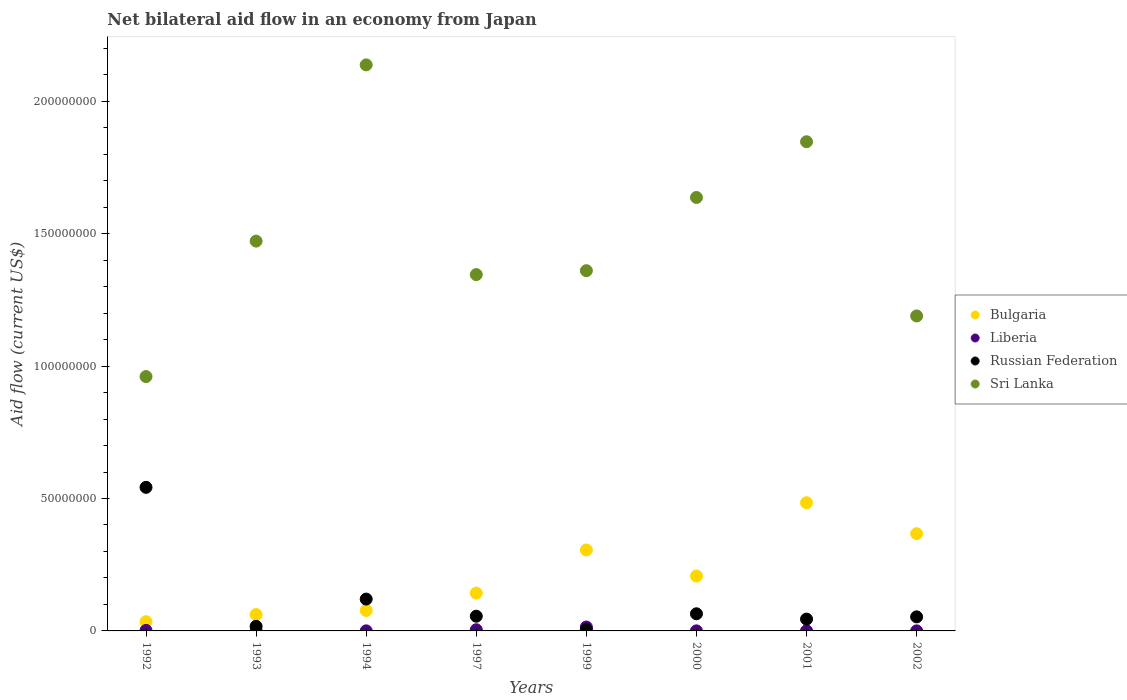What is the net bilateral aid flow in Sri Lanka in 1994?
Keep it short and to the point. 2.14e+08. Across all years, what is the maximum net bilateral aid flow in Liberia?
Ensure brevity in your answer.  1.47e+06. In which year was the net bilateral aid flow in Sri Lanka minimum?
Keep it short and to the point. 1992. What is the total net bilateral aid flow in Russian Federation in the graph?
Your answer should be compact. 9.03e+07. What is the difference between the net bilateral aid flow in Russian Federation in 1993 and that in 2002?
Provide a succinct answer. -3.57e+06. What is the difference between the net bilateral aid flow in Bulgaria in 1993 and the net bilateral aid flow in Liberia in 2001?
Provide a succinct answer. 6.13e+06. What is the average net bilateral aid flow in Sri Lanka per year?
Keep it short and to the point. 1.49e+08. In the year 2002, what is the difference between the net bilateral aid flow in Bulgaria and net bilateral aid flow in Russian Federation?
Your answer should be very brief. 3.14e+07. In how many years, is the net bilateral aid flow in Bulgaria greater than 80000000 US$?
Ensure brevity in your answer.  0. What is the ratio of the net bilateral aid flow in Sri Lanka in 1997 to that in 2002?
Your response must be concise. 1.13. Is the net bilateral aid flow in Bulgaria in 1993 less than that in 2000?
Ensure brevity in your answer.  Yes. Is the difference between the net bilateral aid flow in Bulgaria in 1993 and 2000 greater than the difference between the net bilateral aid flow in Russian Federation in 1993 and 2000?
Ensure brevity in your answer.  No. What is the difference between the highest and the second highest net bilateral aid flow in Bulgaria?
Offer a very short reply. 1.17e+07. What is the difference between the highest and the lowest net bilateral aid flow in Russian Federation?
Ensure brevity in your answer.  5.37e+07. Is the sum of the net bilateral aid flow in Bulgaria in 1999 and 2002 greater than the maximum net bilateral aid flow in Sri Lanka across all years?
Ensure brevity in your answer.  No. Is it the case that in every year, the sum of the net bilateral aid flow in Liberia and net bilateral aid flow in Sri Lanka  is greater than the net bilateral aid flow in Russian Federation?
Your response must be concise. Yes. Is the net bilateral aid flow in Bulgaria strictly greater than the net bilateral aid flow in Liberia over the years?
Offer a terse response. Yes. How many dotlines are there?
Provide a short and direct response. 4. What is the difference between two consecutive major ticks on the Y-axis?
Your answer should be very brief. 5.00e+07. Are the values on the major ticks of Y-axis written in scientific E-notation?
Your answer should be compact. No. Does the graph contain any zero values?
Offer a terse response. No. Does the graph contain grids?
Your answer should be very brief. No. What is the title of the graph?
Offer a very short reply. Net bilateral aid flow in an economy from Japan. Does "European Union" appear as one of the legend labels in the graph?
Provide a succinct answer. No. What is the label or title of the Y-axis?
Give a very brief answer. Aid flow (current US$). What is the Aid flow (current US$) in Bulgaria in 1992?
Keep it short and to the point. 3.48e+06. What is the Aid flow (current US$) of Liberia in 1992?
Ensure brevity in your answer.  2.00e+05. What is the Aid flow (current US$) of Russian Federation in 1992?
Offer a terse response. 5.42e+07. What is the Aid flow (current US$) in Sri Lanka in 1992?
Keep it short and to the point. 9.60e+07. What is the Aid flow (current US$) in Bulgaria in 1993?
Your answer should be very brief. 6.18e+06. What is the Aid flow (current US$) in Liberia in 1993?
Offer a very short reply. 6.00e+04. What is the Aid flow (current US$) in Russian Federation in 1993?
Your answer should be very brief. 1.74e+06. What is the Aid flow (current US$) of Sri Lanka in 1993?
Your response must be concise. 1.47e+08. What is the Aid flow (current US$) of Bulgaria in 1994?
Give a very brief answer. 7.72e+06. What is the Aid flow (current US$) in Russian Federation in 1994?
Offer a very short reply. 1.20e+07. What is the Aid flow (current US$) in Sri Lanka in 1994?
Keep it short and to the point. 2.14e+08. What is the Aid flow (current US$) in Bulgaria in 1997?
Ensure brevity in your answer.  1.43e+07. What is the Aid flow (current US$) in Russian Federation in 1997?
Give a very brief answer. 5.56e+06. What is the Aid flow (current US$) in Sri Lanka in 1997?
Offer a terse response. 1.35e+08. What is the Aid flow (current US$) of Bulgaria in 1999?
Your answer should be compact. 3.06e+07. What is the Aid flow (current US$) in Liberia in 1999?
Offer a very short reply. 1.47e+06. What is the Aid flow (current US$) of Sri Lanka in 1999?
Your answer should be very brief. 1.36e+08. What is the Aid flow (current US$) in Bulgaria in 2000?
Ensure brevity in your answer.  2.07e+07. What is the Aid flow (current US$) in Liberia in 2000?
Provide a succinct answer. 2.00e+04. What is the Aid flow (current US$) in Russian Federation in 2000?
Offer a very short reply. 6.47e+06. What is the Aid flow (current US$) in Sri Lanka in 2000?
Make the answer very short. 1.64e+08. What is the Aid flow (current US$) in Bulgaria in 2001?
Your answer should be very brief. 4.84e+07. What is the Aid flow (current US$) of Liberia in 2001?
Provide a short and direct response. 5.00e+04. What is the Aid flow (current US$) in Russian Federation in 2001?
Your response must be concise. 4.46e+06. What is the Aid flow (current US$) of Sri Lanka in 2001?
Provide a short and direct response. 1.85e+08. What is the Aid flow (current US$) in Bulgaria in 2002?
Offer a very short reply. 3.67e+07. What is the Aid flow (current US$) in Liberia in 2002?
Provide a succinct answer. 2.00e+04. What is the Aid flow (current US$) of Russian Federation in 2002?
Your answer should be compact. 5.31e+06. What is the Aid flow (current US$) of Sri Lanka in 2002?
Ensure brevity in your answer.  1.19e+08. Across all years, what is the maximum Aid flow (current US$) in Bulgaria?
Offer a terse response. 4.84e+07. Across all years, what is the maximum Aid flow (current US$) in Liberia?
Your response must be concise. 1.47e+06. Across all years, what is the maximum Aid flow (current US$) of Russian Federation?
Provide a short and direct response. 5.42e+07. Across all years, what is the maximum Aid flow (current US$) of Sri Lanka?
Your response must be concise. 2.14e+08. Across all years, what is the minimum Aid flow (current US$) of Bulgaria?
Give a very brief answer. 3.48e+06. Across all years, what is the minimum Aid flow (current US$) of Russian Federation?
Give a very brief answer. 5.00e+05. Across all years, what is the minimum Aid flow (current US$) in Sri Lanka?
Offer a very short reply. 9.60e+07. What is the total Aid flow (current US$) of Bulgaria in the graph?
Your response must be concise. 1.68e+08. What is the total Aid flow (current US$) of Liberia in the graph?
Offer a terse response. 2.30e+06. What is the total Aid flow (current US$) of Russian Federation in the graph?
Ensure brevity in your answer.  9.03e+07. What is the total Aid flow (current US$) in Sri Lanka in the graph?
Keep it short and to the point. 1.19e+09. What is the difference between the Aid flow (current US$) of Bulgaria in 1992 and that in 1993?
Your answer should be very brief. -2.70e+06. What is the difference between the Aid flow (current US$) in Liberia in 1992 and that in 1993?
Provide a short and direct response. 1.40e+05. What is the difference between the Aid flow (current US$) of Russian Federation in 1992 and that in 1993?
Provide a short and direct response. 5.25e+07. What is the difference between the Aid flow (current US$) of Sri Lanka in 1992 and that in 1993?
Your answer should be very brief. -5.12e+07. What is the difference between the Aid flow (current US$) of Bulgaria in 1992 and that in 1994?
Your answer should be compact. -4.24e+06. What is the difference between the Aid flow (current US$) in Russian Federation in 1992 and that in 1994?
Your response must be concise. 4.22e+07. What is the difference between the Aid flow (current US$) in Sri Lanka in 1992 and that in 1994?
Give a very brief answer. -1.18e+08. What is the difference between the Aid flow (current US$) of Bulgaria in 1992 and that in 1997?
Your answer should be compact. -1.08e+07. What is the difference between the Aid flow (current US$) of Liberia in 1992 and that in 1997?
Offer a very short reply. -2.50e+05. What is the difference between the Aid flow (current US$) in Russian Federation in 1992 and that in 1997?
Provide a succinct answer. 4.87e+07. What is the difference between the Aid flow (current US$) in Sri Lanka in 1992 and that in 1997?
Provide a short and direct response. -3.85e+07. What is the difference between the Aid flow (current US$) in Bulgaria in 1992 and that in 1999?
Give a very brief answer. -2.71e+07. What is the difference between the Aid flow (current US$) of Liberia in 1992 and that in 1999?
Provide a succinct answer. -1.27e+06. What is the difference between the Aid flow (current US$) in Russian Federation in 1992 and that in 1999?
Make the answer very short. 5.37e+07. What is the difference between the Aid flow (current US$) of Sri Lanka in 1992 and that in 1999?
Provide a succinct answer. -4.00e+07. What is the difference between the Aid flow (current US$) of Bulgaria in 1992 and that in 2000?
Offer a very short reply. -1.72e+07. What is the difference between the Aid flow (current US$) in Russian Federation in 1992 and that in 2000?
Your answer should be very brief. 4.78e+07. What is the difference between the Aid flow (current US$) in Sri Lanka in 1992 and that in 2000?
Ensure brevity in your answer.  -6.76e+07. What is the difference between the Aid flow (current US$) in Bulgaria in 1992 and that in 2001?
Make the answer very short. -4.49e+07. What is the difference between the Aid flow (current US$) in Liberia in 1992 and that in 2001?
Ensure brevity in your answer.  1.50e+05. What is the difference between the Aid flow (current US$) in Russian Federation in 1992 and that in 2001?
Keep it short and to the point. 4.98e+07. What is the difference between the Aid flow (current US$) in Sri Lanka in 1992 and that in 2001?
Your response must be concise. -8.87e+07. What is the difference between the Aid flow (current US$) of Bulgaria in 1992 and that in 2002?
Give a very brief answer. -3.32e+07. What is the difference between the Aid flow (current US$) in Russian Federation in 1992 and that in 2002?
Offer a very short reply. 4.89e+07. What is the difference between the Aid flow (current US$) of Sri Lanka in 1992 and that in 2002?
Your answer should be compact. -2.29e+07. What is the difference between the Aid flow (current US$) of Bulgaria in 1993 and that in 1994?
Provide a succinct answer. -1.54e+06. What is the difference between the Aid flow (current US$) of Liberia in 1993 and that in 1994?
Keep it short and to the point. 3.00e+04. What is the difference between the Aid flow (current US$) in Russian Federation in 1993 and that in 1994?
Keep it short and to the point. -1.03e+07. What is the difference between the Aid flow (current US$) of Sri Lanka in 1993 and that in 1994?
Keep it short and to the point. -6.66e+07. What is the difference between the Aid flow (current US$) in Bulgaria in 1993 and that in 1997?
Ensure brevity in your answer.  -8.11e+06. What is the difference between the Aid flow (current US$) of Liberia in 1993 and that in 1997?
Make the answer very short. -3.90e+05. What is the difference between the Aid flow (current US$) of Russian Federation in 1993 and that in 1997?
Provide a succinct answer. -3.82e+06. What is the difference between the Aid flow (current US$) of Sri Lanka in 1993 and that in 1997?
Offer a terse response. 1.26e+07. What is the difference between the Aid flow (current US$) in Bulgaria in 1993 and that in 1999?
Offer a terse response. -2.44e+07. What is the difference between the Aid flow (current US$) of Liberia in 1993 and that in 1999?
Ensure brevity in your answer.  -1.41e+06. What is the difference between the Aid flow (current US$) in Russian Federation in 1993 and that in 1999?
Ensure brevity in your answer.  1.24e+06. What is the difference between the Aid flow (current US$) in Sri Lanka in 1993 and that in 1999?
Your answer should be compact. 1.12e+07. What is the difference between the Aid flow (current US$) in Bulgaria in 1993 and that in 2000?
Provide a short and direct response. -1.46e+07. What is the difference between the Aid flow (current US$) of Russian Federation in 1993 and that in 2000?
Offer a very short reply. -4.73e+06. What is the difference between the Aid flow (current US$) in Sri Lanka in 1993 and that in 2000?
Give a very brief answer. -1.65e+07. What is the difference between the Aid flow (current US$) in Bulgaria in 1993 and that in 2001?
Offer a terse response. -4.22e+07. What is the difference between the Aid flow (current US$) of Russian Federation in 1993 and that in 2001?
Make the answer very short. -2.72e+06. What is the difference between the Aid flow (current US$) of Sri Lanka in 1993 and that in 2001?
Ensure brevity in your answer.  -3.75e+07. What is the difference between the Aid flow (current US$) of Bulgaria in 1993 and that in 2002?
Give a very brief answer. -3.06e+07. What is the difference between the Aid flow (current US$) of Liberia in 1993 and that in 2002?
Your answer should be very brief. 4.00e+04. What is the difference between the Aid flow (current US$) in Russian Federation in 1993 and that in 2002?
Provide a succinct answer. -3.57e+06. What is the difference between the Aid flow (current US$) in Sri Lanka in 1993 and that in 2002?
Offer a terse response. 2.83e+07. What is the difference between the Aid flow (current US$) in Bulgaria in 1994 and that in 1997?
Make the answer very short. -6.57e+06. What is the difference between the Aid flow (current US$) of Liberia in 1994 and that in 1997?
Offer a terse response. -4.20e+05. What is the difference between the Aid flow (current US$) of Russian Federation in 1994 and that in 1997?
Give a very brief answer. 6.46e+06. What is the difference between the Aid flow (current US$) in Sri Lanka in 1994 and that in 1997?
Your response must be concise. 7.92e+07. What is the difference between the Aid flow (current US$) in Bulgaria in 1994 and that in 1999?
Your answer should be compact. -2.28e+07. What is the difference between the Aid flow (current US$) of Liberia in 1994 and that in 1999?
Ensure brevity in your answer.  -1.44e+06. What is the difference between the Aid flow (current US$) of Russian Federation in 1994 and that in 1999?
Ensure brevity in your answer.  1.15e+07. What is the difference between the Aid flow (current US$) of Sri Lanka in 1994 and that in 1999?
Your answer should be very brief. 7.77e+07. What is the difference between the Aid flow (current US$) in Bulgaria in 1994 and that in 2000?
Give a very brief answer. -1.30e+07. What is the difference between the Aid flow (current US$) in Russian Federation in 1994 and that in 2000?
Make the answer very short. 5.55e+06. What is the difference between the Aid flow (current US$) in Sri Lanka in 1994 and that in 2000?
Your answer should be very brief. 5.01e+07. What is the difference between the Aid flow (current US$) of Bulgaria in 1994 and that in 2001?
Ensure brevity in your answer.  -4.07e+07. What is the difference between the Aid flow (current US$) of Liberia in 1994 and that in 2001?
Give a very brief answer. -2.00e+04. What is the difference between the Aid flow (current US$) in Russian Federation in 1994 and that in 2001?
Provide a short and direct response. 7.56e+06. What is the difference between the Aid flow (current US$) of Sri Lanka in 1994 and that in 2001?
Give a very brief answer. 2.90e+07. What is the difference between the Aid flow (current US$) of Bulgaria in 1994 and that in 2002?
Keep it short and to the point. -2.90e+07. What is the difference between the Aid flow (current US$) in Liberia in 1994 and that in 2002?
Provide a succinct answer. 10000. What is the difference between the Aid flow (current US$) of Russian Federation in 1994 and that in 2002?
Offer a very short reply. 6.71e+06. What is the difference between the Aid flow (current US$) of Sri Lanka in 1994 and that in 2002?
Provide a short and direct response. 9.48e+07. What is the difference between the Aid flow (current US$) in Bulgaria in 1997 and that in 1999?
Keep it short and to the point. -1.63e+07. What is the difference between the Aid flow (current US$) in Liberia in 1997 and that in 1999?
Give a very brief answer. -1.02e+06. What is the difference between the Aid flow (current US$) of Russian Federation in 1997 and that in 1999?
Your answer should be very brief. 5.06e+06. What is the difference between the Aid flow (current US$) in Sri Lanka in 1997 and that in 1999?
Offer a terse response. -1.47e+06. What is the difference between the Aid flow (current US$) in Bulgaria in 1997 and that in 2000?
Make the answer very short. -6.44e+06. What is the difference between the Aid flow (current US$) of Liberia in 1997 and that in 2000?
Your response must be concise. 4.30e+05. What is the difference between the Aid flow (current US$) of Russian Federation in 1997 and that in 2000?
Your answer should be compact. -9.10e+05. What is the difference between the Aid flow (current US$) of Sri Lanka in 1997 and that in 2000?
Give a very brief answer. -2.91e+07. What is the difference between the Aid flow (current US$) of Bulgaria in 1997 and that in 2001?
Provide a short and direct response. -3.41e+07. What is the difference between the Aid flow (current US$) in Russian Federation in 1997 and that in 2001?
Keep it short and to the point. 1.10e+06. What is the difference between the Aid flow (current US$) of Sri Lanka in 1997 and that in 2001?
Provide a succinct answer. -5.02e+07. What is the difference between the Aid flow (current US$) of Bulgaria in 1997 and that in 2002?
Your answer should be compact. -2.24e+07. What is the difference between the Aid flow (current US$) of Russian Federation in 1997 and that in 2002?
Keep it short and to the point. 2.50e+05. What is the difference between the Aid flow (current US$) in Sri Lanka in 1997 and that in 2002?
Give a very brief answer. 1.56e+07. What is the difference between the Aid flow (current US$) of Bulgaria in 1999 and that in 2000?
Your answer should be compact. 9.84e+06. What is the difference between the Aid flow (current US$) in Liberia in 1999 and that in 2000?
Make the answer very short. 1.45e+06. What is the difference between the Aid flow (current US$) of Russian Federation in 1999 and that in 2000?
Provide a succinct answer. -5.97e+06. What is the difference between the Aid flow (current US$) of Sri Lanka in 1999 and that in 2000?
Your answer should be compact. -2.76e+07. What is the difference between the Aid flow (current US$) in Bulgaria in 1999 and that in 2001?
Offer a very short reply. -1.78e+07. What is the difference between the Aid flow (current US$) of Liberia in 1999 and that in 2001?
Give a very brief answer. 1.42e+06. What is the difference between the Aid flow (current US$) in Russian Federation in 1999 and that in 2001?
Ensure brevity in your answer.  -3.96e+06. What is the difference between the Aid flow (current US$) of Sri Lanka in 1999 and that in 2001?
Make the answer very short. -4.87e+07. What is the difference between the Aid flow (current US$) in Bulgaria in 1999 and that in 2002?
Offer a terse response. -6.16e+06. What is the difference between the Aid flow (current US$) of Liberia in 1999 and that in 2002?
Make the answer very short. 1.45e+06. What is the difference between the Aid flow (current US$) of Russian Federation in 1999 and that in 2002?
Ensure brevity in your answer.  -4.81e+06. What is the difference between the Aid flow (current US$) in Sri Lanka in 1999 and that in 2002?
Keep it short and to the point. 1.71e+07. What is the difference between the Aid flow (current US$) in Bulgaria in 2000 and that in 2001?
Your response must be concise. -2.77e+07. What is the difference between the Aid flow (current US$) of Liberia in 2000 and that in 2001?
Ensure brevity in your answer.  -3.00e+04. What is the difference between the Aid flow (current US$) of Russian Federation in 2000 and that in 2001?
Your answer should be very brief. 2.01e+06. What is the difference between the Aid flow (current US$) in Sri Lanka in 2000 and that in 2001?
Your response must be concise. -2.10e+07. What is the difference between the Aid flow (current US$) of Bulgaria in 2000 and that in 2002?
Make the answer very short. -1.60e+07. What is the difference between the Aid flow (current US$) in Liberia in 2000 and that in 2002?
Give a very brief answer. 0. What is the difference between the Aid flow (current US$) of Russian Federation in 2000 and that in 2002?
Your answer should be very brief. 1.16e+06. What is the difference between the Aid flow (current US$) in Sri Lanka in 2000 and that in 2002?
Keep it short and to the point. 4.47e+07. What is the difference between the Aid flow (current US$) in Bulgaria in 2001 and that in 2002?
Your response must be concise. 1.17e+07. What is the difference between the Aid flow (current US$) in Russian Federation in 2001 and that in 2002?
Give a very brief answer. -8.50e+05. What is the difference between the Aid flow (current US$) in Sri Lanka in 2001 and that in 2002?
Ensure brevity in your answer.  6.58e+07. What is the difference between the Aid flow (current US$) in Bulgaria in 1992 and the Aid flow (current US$) in Liberia in 1993?
Keep it short and to the point. 3.42e+06. What is the difference between the Aid flow (current US$) in Bulgaria in 1992 and the Aid flow (current US$) in Russian Federation in 1993?
Give a very brief answer. 1.74e+06. What is the difference between the Aid flow (current US$) in Bulgaria in 1992 and the Aid flow (current US$) in Sri Lanka in 1993?
Your answer should be compact. -1.44e+08. What is the difference between the Aid flow (current US$) in Liberia in 1992 and the Aid flow (current US$) in Russian Federation in 1993?
Give a very brief answer. -1.54e+06. What is the difference between the Aid flow (current US$) of Liberia in 1992 and the Aid flow (current US$) of Sri Lanka in 1993?
Provide a short and direct response. -1.47e+08. What is the difference between the Aid flow (current US$) in Russian Federation in 1992 and the Aid flow (current US$) in Sri Lanka in 1993?
Your response must be concise. -9.30e+07. What is the difference between the Aid flow (current US$) in Bulgaria in 1992 and the Aid flow (current US$) in Liberia in 1994?
Offer a terse response. 3.45e+06. What is the difference between the Aid flow (current US$) in Bulgaria in 1992 and the Aid flow (current US$) in Russian Federation in 1994?
Make the answer very short. -8.54e+06. What is the difference between the Aid flow (current US$) of Bulgaria in 1992 and the Aid flow (current US$) of Sri Lanka in 1994?
Make the answer very short. -2.10e+08. What is the difference between the Aid flow (current US$) in Liberia in 1992 and the Aid flow (current US$) in Russian Federation in 1994?
Give a very brief answer. -1.18e+07. What is the difference between the Aid flow (current US$) of Liberia in 1992 and the Aid flow (current US$) of Sri Lanka in 1994?
Your answer should be compact. -2.14e+08. What is the difference between the Aid flow (current US$) in Russian Federation in 1992 and the Aid flow (current US$) in Sri Lanka in 1994?
Provide a succinct answer. -1.60e+08. What is the difference between the Aid flow (current US$) in Bulgaria in 1992 and the Aid flow (current US$) in Liberia in 1997?
Offer a terse response. 3.03e+06. What is the difference between the Aid flow (current US$) in Bulgaria in 1992 and the Aid flow (current US$) in Russian Federation in 1997?
Your response must be concise. -2.08e+06. What is the difference between the Aid flow (current US$) in Bulgaria in 1992 and the Aid flow (current US$) in Sri Lanka in 1997?
Provide a short and direct response. -1.31e+08. What is the difference between the Aid flow (current US$) in Liberia in 1992 and the Aid flow (current US$) in Russian Federation in 1997?
Your answer should be very brief. -5.36e+06. What is the difference between the Aid flow (current US$) in Liberia in 1992 and the Aid flow (current US$) in Sri Lanka in 1997?
Your answer should be compact. -1.34e+08. What is the difference between the Aid flow (current US$) in Russian Federation in 1992 and the Aid flow (current US$) in Sri Lanka in 1997?
Offer a very short reply. -8.03e+07. What is the difference between the Aid flow (current US$) in Bulgaria in 1992 and the Aid flow (current US$) in Liberia in 1999?
Your answer should be very brief. 2.01e+06. What is the difference between the Aid flow (current US$) in Bulgaria in 1992 and the Aid flow (current US$) in Russian Federation in 1999?
Make the answer very short. 2.98e+06. What is the difference between the Aid flow (current US$) in Bulgaria in 1992 and the Aid flow (current US$) in Sri Lanka in 1999?
Provide a short and direct response. -1.33e+08. What is the difference between the Aid flow (current US$) in Liberia in 1992 and the Aid flow (current US$) in Russian Federation in 1999?
Your response must be concise. -3.00e+05. What is the difference between the Aid flow (current US$) in Liberia in 1992 and the Aid flow (current US$) in Sri Lanka in 1999?
Your answer should be compact. -1.36e+08. What is the difference between the Aid flow (current US$) of Russian Federation in 1992 and the Aid flow (current US$) of Sri Lanka in 1999?
Ensure brevity in your answer.  -8.18e+07. What is the difference between the Aid flow (current US$) in Bulgaria in 1992 and the Aid flow (current US$) in Liberia in 2000?
Provide a short and direct response. 3.46e+06. What is the difference between the Aid flow (current US$) of Bulgaria in 1992 and the Aid flow (current US$) of Russian Federation in 2000?
Offer a very short reply. -2.99e+06. What is the difference between the Aid flow (current US$) of Bulgaria in 1992 and the Aid flow (current US$) of Sri Lanka in 2000?
Ensure brevity in your answer.  -1.60e+08. What is the difference between the Aid flow (current US$) in Liberia in 1992 and the Aid flow (current US$) in Russian Federation in 2000?
Give a very brief answer. -6.27e+06. What is the difference between the Aid flow (current US$) in Liberia in 1992 and the Aid flow (current US$) in Sri Lanka in 2000?
Provide a short and direct response. -1.63e+08. What is the difference between the Aid flow (current US$) of Russian Federation in 1992 and the Aid flow (current US$) of Sri Lanka in 2000?
Offer a very short reply. -1.09e+08. What is the difference between the Aid flow (current US$) in Bulgaria in 1992 and the Aid flow (current US$) in Liberia in 2001?
Ensure brevity in your answer.  3.43e+06. What is the difference between the Aid flow (current US$) in Bulgaria in 1992 and the Aid flow (current US$) in Russian Federation in 2001?
Give a very brief answer. -9.80e+05. What is the difference between the Aid flow (current US$) of Bulgaria in 1992 and the Aid flow (current US$) of Sri Lanka in 2001?
Ensure brevity in your answer.  -1.81e+08. What is the difference between the Aid flow (current US$) in Liberia in 1992 and the Aid flow (current US$) in Russian Federation in 2001?
Your answer should be very brief. -4.26e+06. What is the difference between the Aid flow (current US$) of Liberia in 1992 and the Aid flow (current US$) of Sri Lanka in 2001?
Provide a succinct answer. -1.85e+08. What is the difference between the Aid flow (current US$) in Russian Federation in 1992 and the Aid flow (current US$) in Sri Lanka in 2001?
Keep it short and to the point. -1.30e+08. What is the difference between the Aid flow (current US$) of Bulgaria in 1992 and the Aid flow (current US$) of Liberia in 2002?
Keep it short and to the point. 3.46e+06. What is the difference between the Aid flow (current US$) of Bulgaria in 1992 and the Aid flow (current US$) of Russian Federation in 2002?
Your answer should be compact. -1.83e+06. What is the difference between the Aid flow (current US$) in Bulgaria in 1992 and the Aid flow (current US$) in Sri Lanka in 2002?
Offer a very short reply. -1.15e+08. What is the difference between the Aid flow (current US$) in Liberia in 1992 and the Aid flow (current US$) in Russian Federation in 2002?
Your answer should be very brief. -5.11e+06. What is the difference between the Aid flow (current US$) of Liberia in 1992 and the Aid flow (current US$) of Sri Lanka in 2002?
Give a very brief answer. -1.19e+08. What is the difference between the Aid flow (current US$) in Russian Federation in 1992 and the Aid flow (current US$) in Sri Lanka in 2002?
Offer a terse response. -6.47e+07. What is the difference between the Aid flow (current US$) of Bulgaria in 1993 and the Aid flow (current US$) of Liberia in 1994?
Your response must be concise. 6.15e+06. What is the difference between the Aid flow (current US$) in Bulgaria in 1993 and the Aid flow (current US$) in Russian Federation in 1994?
Provide a short and direct response. -5.84e+06. What is the difference between the Aid flow (current US$) of Bulgaria in 1993 and the Aid flow (current US$) of Sri Lanka in 1994?
Provide a succinct answer. -2.08e+08. What is the difference between the Aid flow (current US$) in Liberia in 1993 and the Aid flow (current US$) in Russian Federation in 1994?
Give a very brief answer. -1.20e+07. What is the difference between the Aid flow (current US$) in Liberia in 1993 and the Aid flow (current US$) in Sri Lanka in 1994?
Your response must be concise. -2.14e+08. What is the difference between the Aid flow (current US$) of Russian Federation in 1993 and the Aid flow (current US$) of Sri Lanka in 1994?
Provide a succinct answer. -2.12e+08. What is the difference between the Aid flow (current US$) of Bulgaria in 1993 and the Aid flow (current US$) of Liberia in 1997?
Ensure brevity in your answer.  5.73e+06. What is the difference between the Aid flow (current US$) of Bulgaria in 1993 and the Aid flow (current US$) of Russian Federation in 1997?
Your response must be concise. 6.20e+05. What is the difference between the Aid flow (current US$) in Bulgaria in 1993 and the Aid flow (current US$) in Sri Lanka in 1997?
Offer a very short reply. -1.28e+08. What is the difference between the Aid flow (current US$) of Liberia in 1993 and the Aid flow (current US$) of Russian Federation in 1997?
Ensure brevity in your answer.  -5.50e+06. What is the difference between the Aid flow (current US$) in Liberia in 1993 and the Aid flow (current US$) in Sri Lanka in 1997?
Provide a succinct answer. -1.34e+08. What is the difference between the Aid flow (current US$) of Russian Federation in 1993 and the Aid flow (current US$) of Sri Lanka in 1997?
Provide a short and direct response. -1.33e+08. What is the difference between the Aid flow (current US$) in Bulgaria in 1993 and the Aid flow (current US$) in Liberia in 1999?
Offer a very short reply. 4.71e+06. What is the difference between the Aid flow (current US$) of Bulgaria in 1993 and the Aid flow (current US$) of Russian Federation in 1999?
Your answer should be compact. 5.68e+06. What is the difference between the Aid flow (current US$) of Bulgaria in 1993 and the Aid flow (current US$) of Sri Lanka in 1999?
Offer a terse response. -1.30e+08. What is the difference between the Aid flow (current US$) of Liberia in 1993 and the Aid flow (current US$) of Russian Federation in 1999?
Provide a succinct answer. -4.40e+05. What is the difference between the Aid flow (current US$) in Liberia in 1993 and the Aid flow (current US$) in Sri Lanka in 1999?
Give a very brief answer. -1.36e+08. What is the difference between the Aid flow (current US$) of Russian Federation in 1993 and the Aid flow (current US$) of Sri Lanka in 1999?
Offer a very short reply. -1.34e+08. What is the difference between the Aid flow (current US$) of Bulgaria in 1993 and the Aid flow (current US$) of Liberia in 2000?
Offer a very short reply. 6.16e+06. What is the difference between the Aid flow (current US$) in Bulgaria in 1993 and the Aid flow (current US$) in Sri Lanka in 2000?
Ensure brevity in your answer.  -1.58e+08. What is the difference between the Aid flow (current US$) in Liberia in 1993 and the Aid flow (current US$) in Russian Federation in 2000?
Provide a succinct answer. -6.41e+06. What is the difference between the Aid flow (current US$) in Liberia in 1993 and the Aid flow (current US$) in Sri Lanka in 2000?
Your response must be concise. -1.64e+08. What is the difference between the Aid flow (current US$) in Russian Federation in 1993 and the Aid flow (current US$) in Sri Lanka in 2000?
Your answer should be very brief. -1.62e+08. What is the difference between the Aid flow (current US$) in Bulgaria in 1993 and the Aid flow (current US$) in Liberia in 2001?
Keep it short and to the point. 6.13e+06. What is the difference between the Aid flow (current US$) in Bulgaria in 1993 and the Aid flow (current US$) in Russian Federation in 2001?
Your answer should be compact. 1.72e+06. What is the difference between the Aid flow (current US$) of Bulgaria in 1993 and the Aid flow (current US$) of Sri Lanka in 2001?
Ensure brevity in your answer.  -1.79e+08. What is the difference between the Aid flow (current US$) of Liberia in 1993 and the Aid flow (current US$) of Russian Federation in 2001?
Offer a very short reply. -4.40e+06. What is the difference between the Aid flow (current US$) in Liberia in 1993 and the Aid flow (current US$) in Sri Lanka in 2001?
Offer a terse response. -1.85e+08. What is the difference between the Aid flow (current US$) of Russian Federation in 1993 and the Aid flow (current US$) of Sri Lanka in 2001?
Provide a succinct answer. -1.83e+08. What is the difference between the Aid flow (current US$) of Bulgaria in 1993 and the Aid flow (current US$) of Liberia in 2002?
Offer a terse response. 6.16e+06. What is the difference between the Aid flow (current US$) of Bulgaria in 1993 and the Aid flow (current US$) of Russian Federation in 2002?
Ensure brevity in your answer.  8.70e+05. What is the difference between the Aid flow (current US$) of Bulgaria in 1993 and the Aid flow (current US$) of Sri Lanka in 2002?
Offer a very short reply. -1.13e+08. What is the difference between the Aid flow (current US$) of Liberia in 1993 and the Aid flow (current US$) of Russian Federation in 2002?
Give a very brief answer. -5.25e+06. What is the difference between the Aid flow (current US$) in Liberia in 1993 and the Aid flow (current US$) in Sri Lanka in 2002?
Offer a terse response. -1.19e+08. What is the difference between the Aid flow (current US$) of Russian Federation in 1993 and the Aid flow (current US$) of Sri Lanka in 2002?
Give a very brief answer. -1.17e+08. What is the difference between the Aid flow (current US$) of Bulgaria in 1994 and the Aid flow (current US$) of Liberia in 1997?
Your response must be concise. 7.27e+06. What is the difference between the Aid flow (current US$) in Bulgaria in 1994 and the Aid flow (current US$) in Russian Federation in 1997?
Offer a terse response. 2.16e+06. What is the difference between the Aid flow (current US$) in Bulgaria in 1994 and the Aid flow (current US$) in Sri Lanka in 1997?
Provide a succinct answer. -1.27e+08. What is the difference between the Aid flow (current US$) of Liberia in 1994 and the Aid flow (current US$) of Russian Federation in 1997?
Make the answer very short. -5.53e+06. What is the difference between the Aid flow (current US$) in Liberia in 1994 and the Aid flow (current US$) in Sri Lanka in 1997?
Provide a short and direct response. -1.35e+08. What is the difference between the Aid flow (current US$) in Russian Federation in 1994 and the Aid flow (current US$) in Sri Lanka in 1997?
Provide a short and direct response. -1.23e+08. What is the difference between the Aid flow (current US$) in Bulgaria in 1994 and the Aid flow (current US$) in Liberia in 1999?
Your answer should be compact. 6.25e+06. What is the difference between the Aid flow (current US$) in Bulgaria in 1994 and the Aid flow (current US$) in Russian Federation in 1999?
Offer a very short reply. 7.22e+06. What is the difference between the Aid flow (current US$) of Bulgaria in 1994 and the Aid flow (current US$) of Sri Lanka in 1999?
Make the answer very short. -1.28e+08. What is the difference between the Aid flow (current US$) in Liberia in 1994 and the Aid flow (current US$) in Russian Federation in 1999?
Offer a very short reply. -4.70e+05. What is the difference between the Aid flow (current US$) of Liberia in 1994 and the Aid flow (current US$) of Sri Lanka in 1999?
Your answer should be compact. -1.36e+08. What is the difference between the Aid flow (current US$) in Russian Federation in 1994 and the Aid flow (current US$) in Sri Lanka in 1999?
Your answer should be compact. -1.24e+08. What is the difference between the Aid flow (current US$) of Bulgaria in 1994 and the Aid flow (current US$) of Liberia in 2000?
Provide a succinct answer. 7.70e+06. What is the difference between the Aid flow (current US$) in Bulgaria in 1994 and the Aid flow (current US$) in Russian Federation in 2000?
Give a very brief answer. 1.25e+06. What is the difference between the Aid flow (current US$) in Bulgaria in 1994 and the Aid flow (current US$) in Sri Lanka in 2000?
Keep it short and to the point. -1.56e+08. What is the difference between the Aid flow (current US$) in Liberia in 1994 and the Aid flow (current US$) in Russian Federation in 2000?
Offer a terse response. -6.44e+06. What is the difference between the Aid flow (current US$) in Liberia in 1994 and the Aid flow (current US$) in Sri Lanka in 2000?
Your response must be concise. -1.64e+08. What is the difference between the Aid flow (current US$) in Russian Federation in 1994 and the Aid flow (current US$) in Sri Lanka in 2000?
Provide a succinct answer. -1.52e+08. What is the difference between the Aid flow (current US$) in Bulgaria in 1994 and the Aid flow (current US$) in Liberia in 2001?
Keep it short and to the point. 7.67e+06. What is the difference between the Aid flow (current US$) in Bulgaria in 1994 and the Aid flow (current US$) in Russian Federation in 2001?
Make the answer very short. 3.26e+06. What is the difference between the Aid flow (current US$) in Bulgaria in 1994 and the Aid flow (current US$) in Sri Lanka in 2001?
Provide a succinct answer. -1.77e+08. What is the difference between the Aid flow (current US$) of Liberia in 1994 and the Aid flow (current US$) of Russian Federation in 2001?
Your response must be concise. -4.43e+06. What is the difference between the Aid flow (current US$) of Liberia in 1994 and the Aid flow (current US$) of Sri Lanka in 2001?
Offer a terse response. -1.85e+08. What is the difference between the Aid flow (current US$) of Russian Federation in 1994 and the Aid flow (current US$) of Sri Lanka in 2001?
Keep it short and to the point. -1.73e+08. What is the difference between the Aid flow (current US$) in Bulgaria in 1994 and the Aid flow (current US$) in Liberia in 2002?
Offer a very short reply. 7.70e+06. What is the difference between the Aid flow (current US$) in Bulgaria in 1994 and the Aid flow (current US$) in Russian Federation in 2002?
Your response must be concise. 2.41e+06. What is the difference between the Aid flow (current US$) in Bulgaria in 1994 and the Aid flow (current US$) in Sri Lanka in 2002?
Provide a succinct answer. -1.11e+08. What is the difference between the Aid flow (current US$) in Liberia in 1994 and the Aid flow (current US$) in Russian Federation in 2002?
Your answer should be compact. -5.28e+06. What is the difference between the Aid flow (current US$) of Liberia in 1994 and the Aid flow (current US$) of Sri Lanka in 2002?
Offer a terse response. -1.19e+08. What is the difference between the Aid flow (current US$) in Russian Federation in 1994 and the Aid flow (current US$) in Sri Lanka in 2002?
Your answer should be very brief. -1.07e+08. What is the difference between the Aid flow (current US$) in Bulgaria in 1997 and the Aid flow (current US$) in Liberia in 1999?
Keep it short and to the point. 1.28e+07. What is the difference between the Aid flow (current US$) of Bulgaria in 1997 and the Aid flow (current US$) of Russian Federation in 1999?
Provide a short and direct response. 1.38e+07. What is the difference between the Aid flow (current US$) in Bulgaria in 1997 and the Aid flow (current US$) in Sri Lanka in 1999?
Keep it short and to the point. -1.22e+08. What is the difference between the Aid flow (current US$) in Liberia in 1997 and the Aid flow (current US$) in Sri Lanka in 1999?
Provide a succinct answer. -1.36e+08. What is the difference between the Aid flow (current US$) in Russian Federation in 1997 and the Aid flow (current US$) in Sri Lanka in 1999?
Keep it short and to the point. -1.30e+08. What is the difference between the Aid flow (current US$) of Bulgaria in 1997 and the Aid flow (current US$) of Liberia in 2000?
Provide a short and direct response. 1.43e+07. What is the difference between the Aid flow (current US$) in Bulgaria in 1997 and the Aid flow (current US$) in Russian Federation in 2000?
Provide a short and direct response. 7.82e+06. What is the difference between the Aid flow (current US$) of Bulgaria in 1997 and the Aid flow (current US$) of Sri Lanka in 2000?
Your answer should be very brief. -1.49e+08. What is the difference between the Aid flow (current US$) in Liberia in 1997 and the Aid flow (current US$) in Russian Federation in 2000?
Provide a short and direct response. -6.02e+06. What is the difference between the Aid flow (current US$) in Liberia in 1997 and the Aid flow (current US$) in Sri Lanka in 2000?
Your answer should be very brief. -1.63e+08. What is the difference between the Aid flow (current US$) in Russian Federation in 1997 and the Aid flow (current US$) in Sri Lanka in 2000?
Offer a terse response. -1.58e+08. What is the difference between the Aid flow (current US$) of Bulgaria in 1997 and the Aid flow (current US$) of Liberia in 2001?
Provide a succinct answer. 1.42e+07. What is the difference between the Aid flow (current US$) of Bulgaria in 1997 and the Aid flow (current US$) of Russian Federation in 2001?
Provide a short and direct response. 9.83e+06. What is the difference between the Aid flow (current US$) of Bulgaria in 1997 and the Aid flow (current US$) of Sri Lanka in 2001?
Keep it short and to the point. -1.70e+08. What is the difference between the Aid flow (current US$) in Liberia in 1997 and the Aid flow (current US$) in Russian Federation in 2001?
Provide a succinct answer. -4.01e+06. What is the difference between the Aid flow (current US$) in Liberia in 1997 and the Aid flow (current US$) in Sri Lanka in 2001?
Make the answer very short. -1.84e+08. What is the difference between the Aid flow (current US$) of Russian Federation in 1997 and the Aid flow (current US$) of Sri Lanka in 2001?
Provide a short and direct response. -1.79e+08. What is the difference between the Aid flow (current US$) of Bulgaria in 1997 and the Aid flow (current US$) of Liberia in 2002?
Ensure brevity in your answer.  1.43e+07. What is the difference between the Aid flow (current US$) of Bulgaria in 1997 and the Aid flow (current US$) of Russian Federation in 2002?
Your response must be concise. 8.98e+06. What is the difference between the Aid flow (current US$) in Bulgaria in 1997 and the Aid flow (current US$) in Sri Lanka in 2002?
Your answer should be compact. -1.05e+08. What is the difference between the Aid flow (current US$) in Liberia in 1997 and the Aid flow (current US$) in Russian Federation in 2002?
Ensure brevity in your answer.  -4.86e+06. What is the difference between the Aid flow (current US$) in Liberia in 1997 and the Aid flow (current US$) in Sri Lanka in 2002?
Offer a very short reply. -1.18e+08. What is the difference between the Aid flow (current US$) of Russian Federation in 1997 and the Aid flow (current US$) of Sri Lanka in 2002?
Offer a very short reply. -1.13e+08. What is the difference between the Aid flow (current US$) of Bulgaria in 1999 and the Aid flow (current US$) of Liberia in 2000?
Offer a terse response. 3.06e+07. What is the difference between the Aid flow (current US$) of Bulgaria in 1999 and the Aid flow (current US$) of Russian Federation in 2000?
Give a very brief answer. 2.41e+07. What is the difference between the Aid flow (current US$) of Bulgaria in 1999 and the Aid flow (current US$) of Sri Lanka in 2000?
Give a very brief answer. -1.33e+08. What is the difference between the Aid flow (current US$) in Liberia in 1999 and the Aid flow (current US$) in Russian Federation in 2000?
Give a very brief answer. -5.00e+06. What is the difference between the Aid flow (current US$) in Liberia in 1999 and the Aid flow (current US$) in Sri Lanka in 2000?
Provide a succinct answer. -1.62e+08. What is the difference between the Aid flow (current US$) in Russian Federation in 1999 and the Aid flow (current US$) in Sri Lanka in 2000?
Your response must be concise. -1.63e+08. What is the difference between the Aid flow (current US$) of Bulgaria in 1999 and the Aid flow (current US$) of Liberia in 2001?
Provide a succinct answer. 3.05e+07. What is the difference between the Aid flow (current US$) in Bulgaria in 1999 and the Aid flow (current US$) in Russian Federation in 2001?
Keep it short and to the point. 2.61e+07. What is the difference between the Aid flow (current US$) in Bulgaria in 1999 and the Aid flow (current US$) in Sri Lanka in 2001?
Your answer should be very brief. -1.54e+08. What is the difference between the Aid flow (current US$) in Liberia in 1999 and the Aid flow (current US$) in Russian Federation in 2001?
Ensure brevity in your answer.  -2.99e+06. What is the difference between the Aid flow (current US$) of Liberia in 1999 and the Aid flow (current US$) of Sri Lanka in 2001?
Give a very brief answer. -1.83e+08. What is the difference between the Aid flow (current US$) of Russian Federation in 1999 and the Aid flow (current US$) of Sri Lanka in 2001?
Ensure brevity in your answer.  -1.84e+08. What is the difference between the Aid flow (current US$) of Bulgaria in 1999 and the Aid flow (current US$) of Liberia in 2002?
Make the answer very short. 3.06e+07. What is the difference between the Aid flow (current US$) of Bulgaria in 1999 and the Aid flow (current US$) of Russian Federation in 2002?
Provide a short and direct response. 2.53e+07. What is the difference between the Aid flow (current US$) of Bulgaria in 1999 and the Aid flow (current US$) of Sri Lanka in 2002?
Provide a short and direct response. -8.84e+07. What is the difference between the Aid flow (current US$) of Liberia in 1999 and the Aid flow (current US$) of Russian Federation in 2002?
Offer a very short reply. -3.84e+06. What is the difference between the Aid flow (current US$) in Liberia in 1999 and the Aid flow (current US$) in Sri Lanka in 2002?
Your answer should be compact. -1.17e+08. What is the difference between the Aid flow (current US$) in Russian Federation in 1999 and the Aid flow (current US$) in Sri Lanka in 2002?
Provide a short and direct response. -1.18e+08. What is the difference between the Aid flow (current US$) of Bulgaria in 2000 and the Aid flow (current US$) of Liberia in 2001?
Keep it short and to the point. 2.07e+07. What is the difference between the Aid flow (current US$) of Bulgaria in 2000 and the Aid flow (current US$) of Russian Federation in 2001?
Your answer should be compact. 1.63e+07. What is the difference between the Aid flow (current US$) of Bulgaria in 2000 and the Aid flow (current US$) of Sri Lanka in 2001?
Make the answer very short. -1.64e+08. What is the difference between the Aid flow (current US$) of Liberia in 2000 and the Aid flow (current US$) of Russian Federation in 2001?
Provide a short and direct response. -4.44e+06. What is the difference between the Aid flow (current US$) in Liberia in 2000 and the Aid flow (current US$) in Sri Lanka in 2001?
Ensure brevity in your answer.  -1.85e+08. What is the difference between the Aid flow (current US$) in Russian Federation in 2000 and the Aid flow (current US$) in Sri Lanka in 2001?
Your answer should be compact. -1.78e+08. What is the difference between the Aid flow (current US$) of Bulgaria in 2000 and the Aid flow (current US$) of Liberia in 2002?
Your response must be concise. 2.07e+07. What is the difference between the Aid flow (current US$) of Bulgaria in 2000 and the Aid flow (current US$) of Russian Federation in 2002?
Your answer should be very brief. 1.54e+07. What is the difference between the Aid flow (current US$) in Bulgaria in 2000 and the Aid flow (current US$) in Sri Lanka in 2002?
Your answer should be compact. -9.82e+07. What is the difference between the Aid flow (current US$) of Liberia in 2000 and the Aid flow (current US$) of Russian Federation in 2002?
Ensure brevity in your answer.  -5.29e+06. What is the difference between the Aid flow (current US$) in Liberia in 2000 and the Aid flow (current US$) in Sri Lanka in 2002?
Give a very brief answer. -1.19e+08. What is the difference between the Aid flow (current US$) in Russian Federation in 2000 and the Aid flow (current US$) in Sri Lanka in 2002?
Offer a very short reply. -1.12e+08. What is the difference between the Aid flow (current US$) in Bulgaria in 2001 and the Aid flow (current US$) in Liberia in 2002?
Keep it short and to the point. 4.84e+07. What is the difference between the Aid flow (current US$) in Bulgaria in 2001 and the Aid flow (current US$) in Russian Federation in 2002?
Provide a succinct answer. 4.31e+07. What is the difference between the Aid flow (current US$) of Bulgaria in 2001 and the Aid flow (current US$) of Sri Lanka in 2002?
Your answer should be very brief. -7.05e+07. What is the difference between the Aid flow (current US$) in Liberia in 2001 and the Aid flow (current US$) in Russian Federation in 2002?
Provide a succinct answer. -5.26e+06. What is the difference between the Aid flow (current US$) of Liberia in 2001 and the Aid flow (current US$) of Sri Lanka in 2002?
Make the answer very short. -1.19e+08. What is the difference between the Aid flow (current US$) in Russian Federation in 2001 and the Aid flow (current US$) in Sri Lanka in 2002?
Provide a short and direct response. -1.14e+08. What is the average Aid flow (current US$) of Bulgaria per year?
Provide a short and direct response. 2.10e+07. What is the average Aid flow (current US$) in Liberia per year?
Your answer should be very brief. 2.88e+05. What is the average Aid flow (current US$) in Russian Federation per year?
Offer a terse response. 1.13e+07. What is the average Aid flow (current US$) in Sri Lanka per year?
Offer a very short reply. 1.49e+08. In the year 1992, what is the difference between the Aid flow (current US$) in Bulgaria and Aid flow (current US$) in Liberia?
Offer a terse response. 3.28e+06. In the year 1992, what is the difference between the Aid flow (current US$) of Bulgaria and Aid flow (current US$) of Russian Federation?
Provide a succinct answer. -5.07e+07. In the year 1992, what is the difference between the Aid flow (current US$) of Bulgaria and Aid flow (current US$) of Sri Lanka?
Provide a succinct answer. -9.26e+07. In the year 1992, what is the difference between the Aid flow (current US$) in Liberia and Aid flow (current US$) in Russian Federation?
Give a very brief answer. -5.40e+07. In the year 1992, what is the difference between the Aid flow (current US$) in Liberia and Aid flow (current US$) in Sri Lanka?
Your answer should be very brief. -9.58e+07. In the year 1992, what is the difference between the Aid flow (current US$) in Russian Federation and Aid flow (current US$) in Sri Lanka?
Keep it short and to the point. -4.18e+07. In the year 1993, what is the difference between the Aid flow (current US$) of Bulgaria and Aid flow (current US$) of Liberia?
Ensure brevity in your answer.  6.12e+06. In the year 1993, what is the difference between the Aid flow (current US$) of Bulgaria and Aid flow (current US$) of Russian Federation?
Provide a short and direct response. 4.44e+06. In the year 1993, what is the difference between the Aid flow (current US$) of Bulgaria and Aid flow (current US$) of Sri Lanka?
Your answer should be very brief. -1.41e+08. In the year 1993, what is the difference between the Aid flow (current US$) of Liberia and Aid flow (current US$) of Russian Federation?
Your answer should be very brief. -1.68e+06. In the year 1993, what is the difference between the Aid flow (current US$) in Liberia and Aid flow (current US$) in Sri Lanka?
Offer a terse response. -1.47e+08. In the year 1993, what is the difference between the Aid flow (current US$) of Russian Federation and Aid flow (current US$) of Sri Lanka?
Offer a very short reply. -1.45e+08. In the year 1994, what is the difference between the Aid flow (current US$) in Bulgaria and Aid flow (current US$) in Liberia?
Ensure brevity in your answer.  7.69e+06. In the year 1994, what is the difference between the Aid flow (current US$) of Bulgaria and Aid flow (current US$) of Russian Federation?
Make the answer very short. -4.30e+06. In the year 1994, what is the difference between the Aid flow (current US$) of Bulgaria and Aid flow (current US$) of Sri Lanka?
Your response must be concise. -2.06e+08. In the year 1994, what is the difference between the Aid flow (current US$) of Liberia and Aid flow (current US$) of Russian Federation?
Your response must be concise. -1.20e+07. In the year 1994, what is the difference between the Aid flow (current US$) in Liberia and Aid flow (current US$) in Sri Lanka?
Offer a very short reply. -2.14e+08. In the year 1994, what is the difference between the Aid flow (current US$) of Russian Federation and Aid flow (current US$) of Sri Lanka?
Offer a terse response. -2.02e+08. In the year 1997, what is the difference between the Aid flow (current US$) in Bulgaria and Aid flow (current US$) in Liberia?
Keep it short and to the point. 1.38e+07. In the year 1997, what is the difference between the Aid flow (current US$) of Bulgaria and Aid flow (current US$) of Russian Federation?
Offer a terse response. 8.73e+06. In the year 1997, what is the difference between the Aid flow (current US$) in Bulgaria and Aid flow (current US$) in Sri Lanka?
Make the answer very short. -1.20e+08. In the year 1997, what is the difference between the Aid flow (current US$) of Liberia and Aid flow (current US$) of Russian Federation?
Your response must be concise. -5.11e+06. In the year 1997, what is the difference between the Aid flow (current US$) of Liberia and Aid flow (current US$) of Sri Lanka?
Provide a succinct answer. -1.34e+08. In the year 1997, what is the difference between the Aid flow (current US$) in Russian Federation and Aid flow (current US$) in Sri Lanka?
Provide a succinct answer. -1.29e+08. In the year 1999, what is the difference between the Aid flow (current US$) of Bulgaria and Aid flow (current US$) of Liberia?
Your answer should be very brief. 2.91e+07. In the year 1999, what is the difference between the Aid flow (current US$) of Bulgaria and Aid flow (current US$) of Russian Federation?
Give a very brief answer. 3.01e+07. In the year 1999, what is the difference between the Aid flow (current US$) in Bulgaria and Aid flow (current US$) in Sri Lanka?
Keep it short and to the point. -1.05e+08. In the year 1999, what is the difference between the Aid flow (current US$) in Liberia and Aid flow (current US$) in Russian Federation?
Ensure brevity in your answer.  9.70e+05. In the year 1999, what is the difference between the Aid flow (current US$) in Liberia and Aid flow (current US$) in Sri Lanka?
Provide a succinct answer. -1.35e+08. In the year 1999, what is the difference between the Aid flow (current US$) in Russian Federation and Aid flow (current US$) in Sri Lanka?
Offer a very short reply. -1.36e+08. In the year 2000, what is the difference between the Aid flow (current US$) of Bulgaria and Aid flow (current US$) of Liberia?
Offer a very short reply. 2.07e+07. In the year 2000, what is the difference between the Aid flow (current US$) in Bulgaria and Aid flow (current US$) in Russian Federation?
Offer a very short reply. 1.43e+07. In the year 2000, what is the difference between the Aid flow (current US$) in Bulgaria and Aid flow (current US$) in Sri Lanka?
Make the answer very short. -1.43e+08. In the year 2000, what is the difference between the Aid flow (current US$) of Liberia and Aid flow (current US$) of Russian Federation?
Give a very brief answer. -6.45e+06. In the year 2000, what is the difference between the Aid flow (current US$) in Liberia and Aid flow (current US$) in Sri Lanka?
Provide a succinct answer. -1.64e+08. In the year 2000, what is the difference between the Aid flow (current US$) in Russian Federation and Aid flow (current US$) in Sri Lanka?
Offer a very short reply. -1.57e+08. In the year 2001, what is the difference between the Aid flow (current US$) in Bulgaria and Aid flow (current US$) in Liberia?
Offer a very short reply. 4.84e+07. In the year 2001, what is the difference between the Aid flow (current US$) in Bulgaria and Aid flow (current US$) in Russian Federation?
Provide a short and direct response. 4.39e+07. In the year 2001, what is the difference between the Aid flow (current US$) in Bulgaria and Aid flow (current US$) in Sri Lanka?
Your answer should be very brief. -1.36e+08. In the year 2001, what is the difference between the Aid flow (current US$) of Liberia and Aid flow (current US$) of Russian Federation?
Keep it short and to the point. -4.41e+06. In the year 2001, what is the difference between the Aid flow (current US$) in Liberia and Aid flow (current US$) in Sri Lanka?
Provide a short and direct response. -1.85e+08. In the year 2001, what is the difference between the Aid flow (current US$) in Russian Federation and Aid flow (current US$) in Sri Lanka?
Offer a very short reply. -1.80e+08. In the year 2002, what is the difference between the Aid flow (current US$) in Bulgaria and Aid flow (current US$) in Liberia?
Your response must be concise. 3.67e+07. In the year 2002, what is the difference between the Aid flow (current US$) of Bulgaria and Aid flow (current US$) of Russian Federation?
Your response must be concise. 3.14e+07. In the year 2002, what is the difference between the Aid flow (current US$) in Bulgaria and Aid flow (current US$) in Sri Lanka?
Your answer should be compact. -8.22e+07. In the year 2002, what is the difference between the Aid flow (current US$) in Liberia and Aid flow (current US$) in Russian Federation?
Provide a succinct answer. -5.29e+06. In the year 2002, what is the difference between the Aid flow (current US$) of Liberia and Aid flow (current US$) of Sri Lanka?
Offer a very short reply. -1.19e+08. In the year 2002, what is the difference between the Aid flow (current US$) in Russian Federation and Aid flow (current US$) in Sri Lanka?
Keep it short and to the point. -1.14e+08. What is the ratio of the Aid flow (current US$) of Bulgaria in 1992 to that in 1993?
Offer a terse response. 0.56. What is the ratio of the Aid flow (current US$) in Liberia in 1992 to that in 1993?
Make the answer very short. 3.33. What is the ratio of the Aid flow (current US$) of Russian Federation in 1992 to that in 1993?
Your answer should be very brief. 31.16. What is the ratio of the Aid flow (current US$) in Sri Lanka in 1992 to that in 1993?
Provide a succinct answer. 0.65. What is the ratio of the Aid flow (current US$) in Bulgaria in 1992 to that in 1994?
Give a very brief answer. 0.45. What is the ratio of the Aid flow (current US$) of Liberia in 1992 to that in 1994?
Keep it short and to the point. 6.67. What is the ratio of the Aid flow (current US$) in Russian Federation in 1992 to that in 1994?
Make the answer very short. 4.51. What is the ratio of the Aid flow (current US$) of Sri Lanka in 1992 to that in 1994?
Your answer should be very brief. 0.45. What is the ratio of the Aid flow (current US$) in Bulgaria in 1992 to that in 1997?
Provide a succinct answer. 0.24. What is the ratio of the Aid flow (current US$) in Liberia in 1992 to that in 1997?
Keep it short and to the point. 0.44. What is the ratio of the Aid flow (current US$) in Russian Federation in 1992 to that in 1997?
Provide a short and direct response. 9.75. What is the ratio of the Aid flow (current US$) in Sri Lanka in 1992 to that in 1997?
Offer a very short reply. 0.71. What is the ratio of the Aid flow (current US$) of Bulgaria in 1992 to that in 1999?
Provide a short and direct response. 0.11. What is the ratio of the Aid flow (current US$) in Liberia in 1992 to that in 1999?
Offer a very short reply. 0.14. What is the ratio of the Aid flow (current US$) of Russian Federation in 1992 to that in 1999?
Give a very brief answer. 108.44. What is the ratio of the Aid flow (current US$) of Sri Lanka in 1992 to that in 1999?
Make the answer very short. 0.71. What is the ratio of the Aid flow (current US$) in Bulgaria in 1992 to that in 2000?
Make the answer very short. 0.17. What is the ratio of the Aid flow (current US$) in Liberia in 1992 to that in 2000?
Give a very brief answer. 10. What is the ratio of the Aid flow (current US$) in Russian Federation in 1992 to that in 2000?
Your answer should be very brief. 8.38. What is the ratio of the Aid flow (current US$) in Sri Lanka in 1992 to that in 2000?
Provide a succinct answer. 0.59. What is the ratio of the Aid flow (current US$) of Bulgaria in 1992 to that in 2001?
Offer a very short reply. 0.07. What is the ratio of the Aid flow (current US$) of Russian Federation in 1992 to that in 2001?
Provide a short and direct response. 12.16. What is the ratio of the Aid flow (current US$) in Sri Lanka in 1992 to that in 2001?
Your answer should be very brief. 0.52. What is the ratio of the Aid flow (current US$) of Bulgaria in 1992 to that in 2002?
Your response must be concise. 0.09. What is the ratio of the Aid flow (current US$) in Russian Federation in 1992 to that in 2002?
Offer a terse response. 10.21. What is the ratio of the Aid flow (current US$) of Sri Lanka in 1992 to that in 2002?
Your response must be concise. 0.81. What is the ratio of the Aid flow (current US$) of Bulgaria in 1993 to that in 1994?
Your answer should be compact. 0.8. What is the ratio of the Aid flow (current US$) of Liberia in 1993 to that in 1994?
Your answer should be very brief. 2. What is the ratio of the Aid flow (current US$) of Russian Federation in 1993 to that in 1994?
Provide a short and direct response. 0.14. What is the ratio of the Aid flow (current US$) of Sri Lanka in 1993 to that in 1994?
Provide a succinct answer. 0.69. What is the ratio of the Aid flow (current US$) in Bulgaria in 1993 to that in 1997?
Your response must be concise. 0.43. What is the ratio of the Aid flow (current US$) of Liberia in 1993 to that in 1997?
Your answer should be compact. 0.13. What is the ratio of the Aid flow (current US$) of Russian Federation in 1993 to that in 1997?
Your response must be concise. 0.31. What is the ratio of the Aid flow (current US$) of Sri Lanka in 1993 to that in 1997?
Make the answer very short. 1.09. What is the ratio of the Aid flow (current US$) in Bulgaria in 1993 to that in 1999?
Provide a short and direct response. 0.2. What is the ratio of the Aid flow (current US$) of Liberia in 1993 to that in 1999?
Offer a terse response. 0.04. What is the ratio of the Aid flow (current US$) in Russian Federation in 1993 to that in 1999?
Offer a terse response. 3.48. What is the ratio of the Aid flow (current US$) in Sri Lanka in 1993 to that in 1999?
Your answer should be compact. 1.08. What is the ratio of the Aid flow (current US$) of Bulgaria in 1993 to that in 2000?
Make the answer very short. 0.3. What is the ratio of the Aid flow (current US$) in Liberia in 1993 to that in 2000?
Offer a terse response. 3. What is the ratio of the Aid flow (current US$) in Russian Federation in 1993 to that in 2000?
Provide a short and direct response. 0.27. What is the ratio of the Aid flow (current US$) in Sri Lanka in 1993 to that in 2000?
Provide a succinct answer. 0.9. What is the ratio of the Aid flow (current US$) in Bulgaria in 1993 to that in 2001?
Offer a very short reply. 0.13. What is the ratio of the Aid flow (current US$) of Liberia in 1993 to that in 2001?
Provide a short and direct response. 1.2. What is the ratio of the Aid flow (current US$) of Russian Federation in 1993 to that in 2001?
Your answer should be compact. 0.39. What is the ratio of the Aid flow (current US$) of Sri Lanka in 1993 to that in 2001?
Your response must be concise. 0.8. What is the ratio of the Aid flow (current US$) of Bulgaria in 1993 to that in 2002?
Offer a very short reply. 0.17. What is the ratio of the Aid flow (current US$) in Russian Federation in 1993 to that in 2002?
Provide a succinct answer. 0.33. What is the ratio of the Aid flow (current US$) in Sri Lanka in 1993 to that in 2002?
Your response must be concise. 1.24. What is the ratio of the Aid flow (current US$) in Bulgaria in 1994 to that in 1997?
Your response must be concise. 0.54. What is the ratio of the Aid flow (current US$) of Liberia in 1994 to that in 1997?
Offer a very short reply. 0.07. What is the ratio of the Aid flow (current US$) of Russian Federation in 1994 to that in 1997?
Offer a very short reply. 2.16. What is the ratio of the Aid flow (current US$) in Sri Lanka in 1994 to that in 1997?
Your response must be concise. 1.59. What is the ratio of the Aid flow (current US$) in Bulgaria in 1994 to that in 1999?
Your answer should be compact. 0.25. What is the ratio of the Aid flow (current US$) of Liberia in 1994 to that in 1999?
Give a very brief answer. 0.02. What is the ratio of the Aid flow (current US$) of Russian Federation in 1994 to that in 1999?
Offer a very short reply. 24.04. What is the ratio of the Aid flow (current US$) of Sri Lanka in 1994 to that in 1999?
Provide a succinct answer. 1.57. What is the ratio of the Aid flow (current US$) in Bulgaria in 1994 to that in 2000?
Your response must be concise. 0.37. What is the ratio of the Aid flow (current US$) of Russian Federation in 1994 to that in 2000?
Offer a terse response. 1.86. What is the ratio of the Aid flow (current US$) of Sri Lanka in 1994 to that in 2000?
Your response must be concise. 1.31. What is the ratio of the Aid flow (current US$) in Bulgaria in 1994 to that in 2001?
Your response must be concise. 0.16. What is the ratio of the Aid flow (current US$) of Russian Federation in 1994 to that in 2001?
Keep it short and to the point. 2.7. What is the ratio of the Aid flow (current US$) in Sri Lanka in 1994 to that in 2001?
Keep it short and to the point. 1.16. What is the ratio of the Aid flow (current US$) of Bulgaria in 1994 to that in 2002?
Your response must be concise. 0.21. What is the ratio of the Aid flow (current US$) of Liberia in 1994 to that in 2002?
Your answer should be compact. 1.5. What is the ratio of the Aid flow (current US$) of Russian Federation in 1994 to that in 2002?
Your answer should be very brief. 2.26. What is the ratio of the Aid flow (current US$) of Sri Lanka in 1994 to that in 2002?
Offer a very short reply. 1.8. What is the ratio of the Aid flow (current US$) in Bulgaria in 1997 to that in 1999?
Provide a short and direct response. 0.47. What is the ratio of the Aid flow (current US$) in Liberia in 1997 to that in 1999?
Make the answer very short. 0.31. What is the ratio of the Aid flow (current US$) in Russian Federation in 1997 to that in 1999?
Ensure brevity in your answer.  11.12. What is the ratio of the Aid flow (current US$) of Sri Lanka in 1997 to that in 1999?
Make the answer very short. 0.99. What is the ratio of the Aid flow (current US$) in Bulgaria in 1997 to that in 2000?
Keep it short and to the point. 0.69. What is the ratio of the Aid flow (current US$) of Russian Federation in 1997 to that in 2000?
Make the answer very short. 0.86. What is the ratio of the Aid flow (current US$) in Sri Lanka in 1997 to that in 2000?
Provide a short and direct response. 0.82. What is the ratio of the Aid flow (current US$) in Bulgaria in 1997 to that in 2001?
Provide a succinct answer. 0.3. What is the ratio of the Aid flow (current US$) in Russian Federation in 1997 to that in 2001?
Ensure brevity in your answer.  1.25. What is the ratio of the Aid flow (current US$) of Sri Lanka in 1997 to that in 2001?
Ensure brevity in your answer.  0.73. What is the ratio of the Aid flow (current US$) of Bulgaria in 1997 to that in 2002?
Make the answer very short. 0.39. What is the ratio of the Aid flow (current US$) of Russian Federation in 1997 to that in 2002?
Offer a terse response. 1.05. What is the ratio of the Aid flow (current US$) of Sri Lanka in 1997 to that in 2002?
Your response must be concise. 1.13. What is the ratio of the Aid flow (current US$) of Bulgaria in 1999 to that in 2000?
Your answer should be compact. 1.47. What is the ratio of the Aid flow (current US$) of Liberia in 1999 to that in 2000?
Your response must be concise. 73.5. What is the ratio of the Aid flow (current US$) in Russian Federation in 1999 to that in 2000?
Ensure brevity in your answer.  0.08. What is the ratio of the Aid flow (current US$) of Sri Lanka in 1999 to that in 2000?
Keep it short and to the point. 0.83. What is the ratio of the Aid flow (current US$) in Bulgaria in 1999 to that in 2001?
Provide a succinct answer. 0.63. What is the ratio of the Aid flow (current US$) of Liberia in 1999 to that in 2001?
Your response must be concise. 29.4. What is the ratio of the Aid flow (current US$) in Russian Federation in 1999 to that in 2001?
Offer a terse response. 0.11. What is the ratio of the Aid flow (current US$) in Sri Lanka in 1999 to that in 2001?
Offer a terse response. 0.74. What is the ratio of the Aid flow (current US$) in Bulgaria in 1999 to that in 2002?
Provide a short and direct response. 0.83. What is the ratio of the Aid flow (current US$) of Liberia in 1999 to that in 2002?
Offer a terse response. 73.5. What is the ratio of the Aid flow (current US$) in Russian Federation in 1999 to that in 2002?
Provide a short and direct response. 0.09. What is the ratio of the Aid flow (current US$) of Sri Lanka in 1999 to that in 2002?
Keep it short and to the point. 1.14. What is the ratio of the Aid flow (current US$) in Bulgaria in 2000 to that in 2001?
Your answer should be very brief. 0.43. What is the ratio of the Aid flow (current US$) of Russian Federation in 2000 to that in 2001?
Your answer should be very brief. 1.45. What is the ratio of the Aid flow (current US$) in Sri Lanka in 2000 to that in 2001?
Offer a terse response. 0.89. What is the ratio of the Aid flow (current US$) in Bulgaria in 2000 to that in 2002?
Your answer should be compact. 0.56. What is the ratio of the Aid flow (current US$) in Liberia in 2000 to that in 2002?
Keep it short and to the point. 1. What is the ratio of the Aid flow (current US$) of Russian Federation in 2000 to that in 2002?
Offer a terse response. 1.22. What is the ratio of the Aid flow (current US$) in Sri Lanka in 2000 to that in 2002?
Provide a succinct answer. 1.38. What is the ratio of the Aid flow (current US$) in Bulgaria in 2001 to that in 2002?
Give a very brief answer. 1.32. What is the ratio of the Aid flow (current US$) of Liberia in 2001 to that in 2002?
Your response must be concise. 2.5. What is the ratio of the Aid flow (current US$) in Russian Federation in 2001 to that in 2002?
Keep it short and to the point. 0.84. What is the ratio of the Aid flow (current US$) of Sri Lanka in 2001 to that in 2002?
Your answer should be very brief. 1.55. What is the difference between the highest and the second highest Aid flow (current US$) in Bulgaria?
Ensure brevity in your answer.  1.17e+07. What is the difference between the highest and the second highest Aid flow (current US$) in Liberia?
Your answer should be compact. 1.02e+06. What is the difference between the highest and the second highest Aid flow (current US$) of Russian Federation?
Offer a very short reply. 4.22e+07. What is the difference between the highest and the second highest Aid flow (current US$) of Sri Lanka?
Ensure brevity in your answer.  2.90e+07. What is the difference between the highest and the lowest Aid flow (current US$) of Bulgaria?
Offer a very short reply. 4.49e+07. What is the difference between the highest and the lowest Aid flow (current US$) in Liberia?
Ensure brevity in your answer.  1.45e+06. What is the difference between the highest and the lowest Aid flow (current US$) in Russian Federation?
Your answer should be compact. 5.37e+07. What is the difference between the highest and the lowest Aid flow (current US$) of Sri Lanka?
Your answer should be compact. 1.18e+08. 